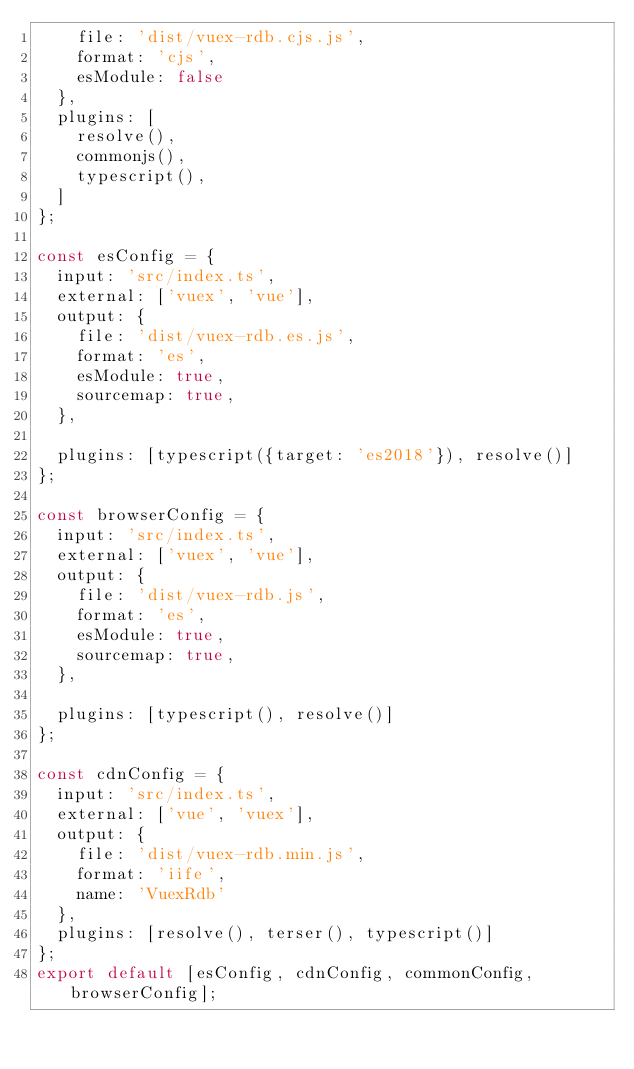<code> <loc_0><loc_0><loc_500><loc_500><_JavaScript_>    file: 'dist/vuex-rdb.cjs.js',
    format: 'cjs',
    esModule: false
  },
  plugins: [
    resolve(),
    commonjs(),
    typescript(),
  ]
};

const esConfig = {
  input: 'src/index.ts',
  external: ['vuex', 'vue'],
  output: {
    file: 'dist/vuex-rdb.es.js',
    format: 'es',
    esModule: true,
    sourcemap: true,
  },

  plugins: [typescript({target: 'es2018'}), resolve()]
};

const browserConfig = {
  input: 'src/index.ts',
  external: ['vuex', 'vue'],
  output: {
    file: 'dist/vuex-rdb.js',
    format: 'es',
    esModule: true,
    sourcemap: true,
  },

  plugins: [typescript(), resolve()]
};

const cdnConfig = {
  input: 'src/index.ts',
  external: ['vue', 'vuex'],
  output: {
    file: 'dist/vuex-rdb.min.js',
    format: 'iife',
    name: 'VuexRdb'
  },
  plugins: [resolve(), terser(), typescript()]
};
export default [esConfig, cdnConfig, commonConfig, browserConfig];
</code> 